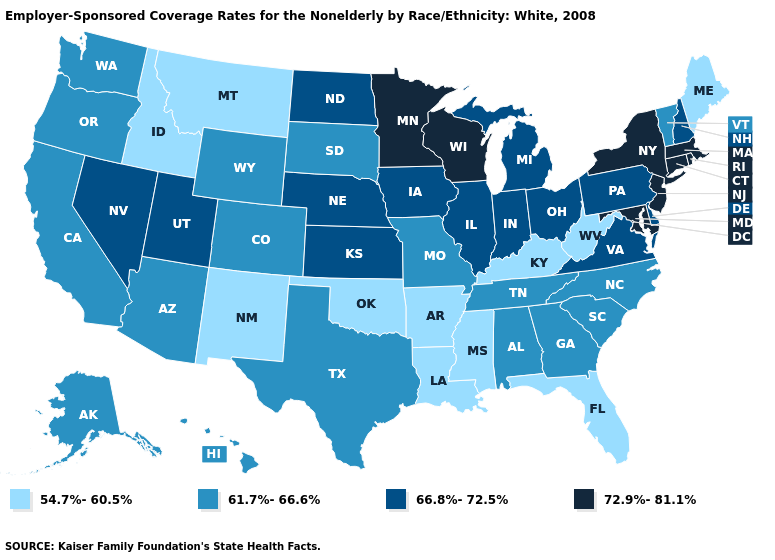Name the states that have a value in the range 61.7%-66.6%?
Give a very brief answer. Alabama, Alaska, Arizona, California, Colorado, Georgia, Hawaii, Missouri, North Carolina, Oregon, South Carolina, South Dakota, Tennessee, Texas, Vermont, Washington, Wyoming. Name the states that have a value in the range 54.7%-60.5%?
Write a very short answer. Arkansas, Florida, Idaho, Kentucky, Louisiana, Maine, Mississippi, Montana, New Mexico, Oklahoma, West Virginia. Does the first symbol in the legend represent the smallest category?
Be succinct. Yes. Name the states that have a value in the range 66.8%-72.5%?
Answer briefly. Delaware, Illinois, Indiana, Iowa, Kansas, Michigan, Nebraska, Nevada, New Hampshire, North Dakota, Ohio, Pennsylvania, Utah, Virginia. Name the states that have a value in the range 54.7%-60.5%?
Keep it brief. Arkansas, Florida, Idaho, Kentucky, Louisiana, Maine, Mississippi, Montana, New Mexico, Oklahoma, West Virginia. What is the highest value in the USA?
Give a very brief answer. 72.9%-81.1%. Name the states that have a value in the range 54.7%-60.5%?
Short answer required. Arkansas, Florida, Idaho, Kentucky, Louisiana, Maine, Mississippi, Montana, New Mexico, Oklahoma, West Virginia. What is the highest value in the USA?
Be succinct. 72.9%-81.1%. Does Oklahoma have the same value as Nevada?
Write a very short answer. No. Does the first symbol in the legend represent the smallest category?
Keep it brief. Yes. Which states have the lowest value in the South?
Be succinct. Arkansas, Florida, Kentucky, Louisiana, Mississippi, Oklahoma, West Virginia. Does Nebraska have a higher value than Kentucky?
Keep it brief. Yes. Does Kansas have the lowest value in the MidWest?
Short answer required. No. What is the lowest value in the USA?
Keep it brief. 54.7%-60.5%. Which states have the lowest value in the Northeast?
Short answer required. Maine. 